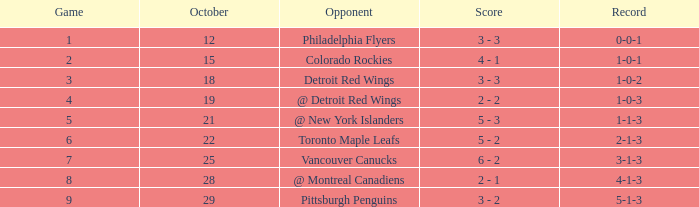Determine the least significant game for october 2 5.0. 